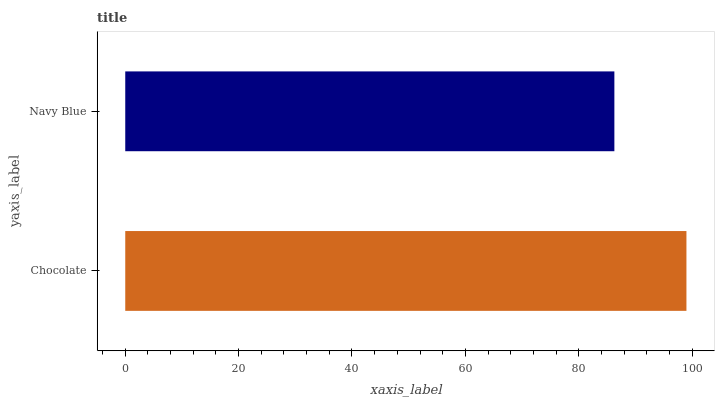Is Navy Blue the minimum?
Answer yes or no. Yes. Is Chocolate the maximum?
Answer yes or no. Yes. Is Navy Blue the maximum?
Answer yes or no. No. Is Chocolate greater than Navy Blue?
Answer yes or no. Yes. Is Navy Blue less than Chocolate?
Answer yes or no. Yes. Is Navy Blue greater than Chocolate?
Answer yes or no. No. Is Chocolate less than Navy Blue?
Answer yes or no. No. Is Chocolate the high median?
Answer yes or no. Yes. Is Navy Blue the low median?
Answer yes or no. Yes. Is Navy Blue the high median?
Answer yes or no. No. Is Chocolate the low median?
Answer yes or no. No. 